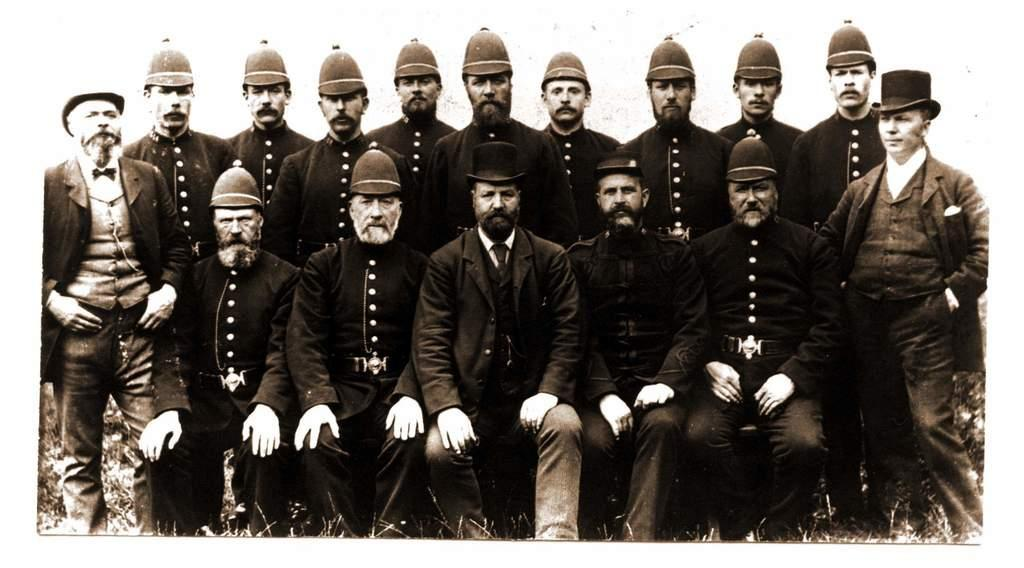What are the people in the image doing? There are people sitting and standing in the image. What are the people wearing on their heads? The people are wearing caps in the image. What type of clothing are the people wearing? The people are wearing uniforms in the image. What is the color scheme of the image? The image is black and white. What type of playground equipment can be seen in the image? There is no playground equipment present in the image. What kind of lumber is visible in the image? There is no lumber visible in the image. 